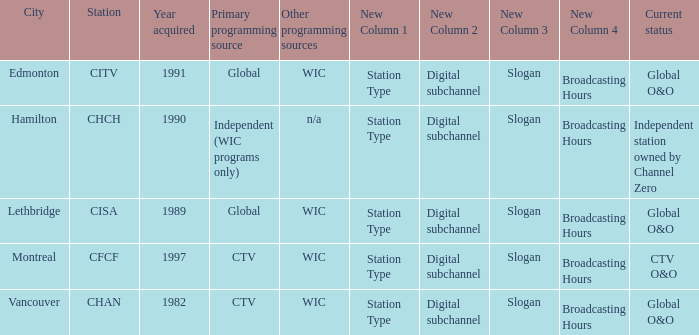How many is the minimum for citv 1991.0. 